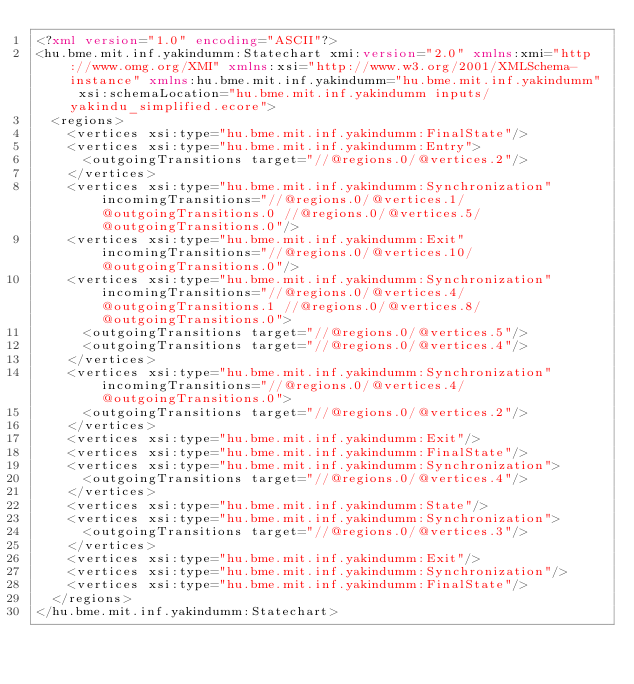<code> <loc_0><loc_0><loc_500><loc_500><_XML_><?xml version="1.0" encoding="ASCII"?>
<hu.bme.mit.inf.yakindumm:Statechart xmi:version="2.0" xmlns:xmi="http://www.omg.org/XMI" xmlns:xsi="http://www.w3.org/2001/XMLSchema-instance" xmlns:hu.bme.mit.inf.yakindumm="hu.bme.mit.inf.yakindumm" xsi:schemaLocation="hu.bme.mit.inf.yakindumm inputs/yakindu_simplified.ecore">
  <regions>
    <vertices xsi:type="hu.bme.mit.inf.yakindumm:FinalState"/>
    <vertices xsi:type="hu.bme.mit.inf.yakindumm:Entry">
      <outgoingTransitions target="//@regions.0/@vertices.2"/>
    </vertices>
    <vertices xsi:type="hu.bme.mit.inf.yakindumm:Synchronization" incomingTransitions="//@regions.0/@vertices.1/@outgoingTransitions.0 //@regions.0/@vertices.5/@outgoingTransitions.0"/>
    <vertices xsi:type="hu.bme.mit.inf.yakindumm:Exit" incomingTransitions="//@regions.0/@vertices.10/@outgoingTransitions.0"/>
    <vertices xsi:type="hu.bme.mit.inf.yakindumm:Synchronization" incomingTransitions="//@regions.0/@vertices.4/@outgoingTransitions.1 //@regions.0/@vertices.8/@outgoingTransitions.0">
      <outgoingTransitions target="//@regions.0/@vertices.5"/>
      <outgoingTransitions target="//@regions.0/@vertices.4"/>
    </vertices>
    <vertices xsi:type="hu.bme.mit.inf.yakindumm:Synchronization" incomingTransitions="//@regions.0/@vertices.4/@outgoingTransitions.0">
      <outgoingTransitions target="//@regions.0/@vertices.2"/>
    </vertices>
    <vertices xsi:type="hu.bme.mit.inf.yakindumm:Exit"/>
    <vertices xsi:type="hu.bme.mit.inf.yakindumm:FinalState"/>
    <vertices xsi:type="hu.bme.mit.inf.yakindumm:Synchronization">
      <outgoingTransitions target="//@regions.0/@vertices.4"/>
    </vertices>
    <vertices xsi:type="hu.bme.mit.inf.yakindumm:State"/>
    <vertices xsi:type="hu.bme.mit.inf.yakindumm:Synchronization">
      <outgoingTransitions target="//@regions.0/@vertices.3"/>
    </vertices>
    <vertices xsi:type="hu.bme.mit.inf.yakindumm:Exit"/>
    <vertices xsi:type="hu.bme.mit.inf.yakindumm:Synchronization"/>
    <vertices xsi:type="hu.bme.mit.inf.yakindumm:FinalState"/>
  </regions>
</hu.bme.mit.inf.yakindumm:Statechart>
</code> 